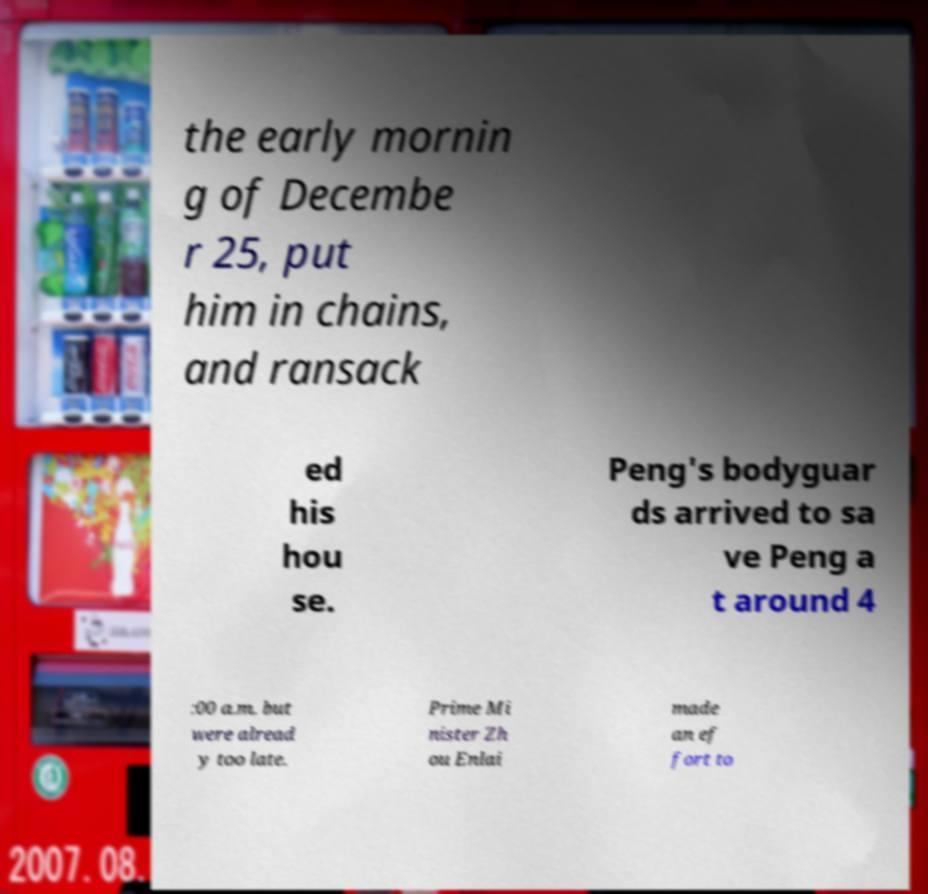Can you read and provide the text displayed in the image?This photo seems to have some interesting text. Can you extract and type it out for me? the early mornin g of Decembe r 25, put him in chains, and ransack ed his hou se. Peng's bodyguar ds arrived to sa ve Peng a t around 4 :00 a.m. but were alread y too late. Prime Mi nister Zh ou Enlai made an ef fort to 